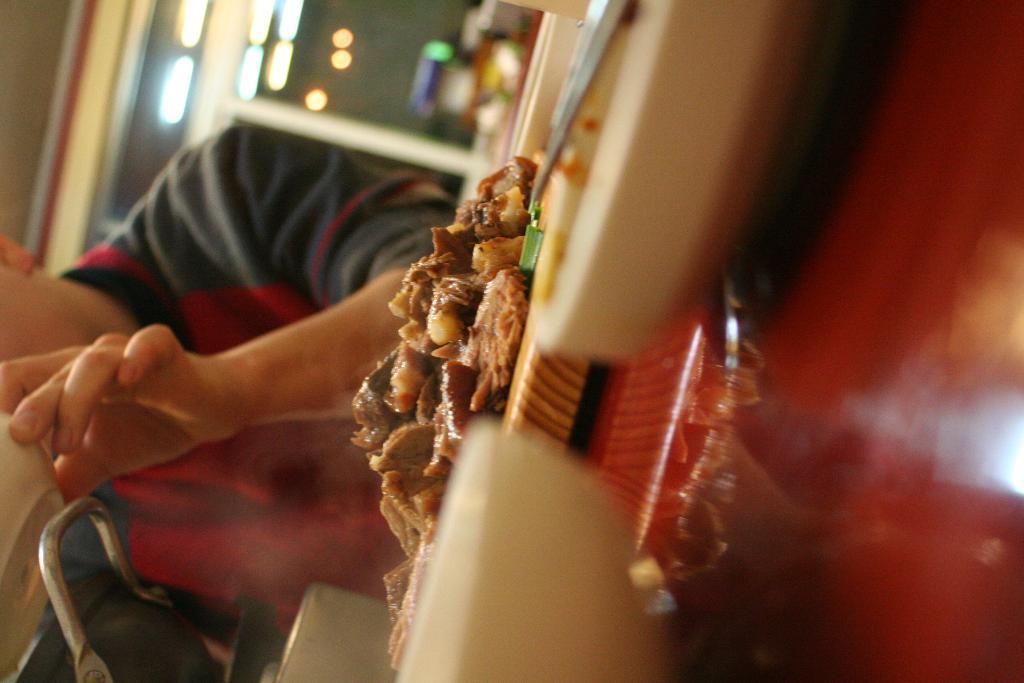In one or two sentences, can you explain what this image depicts? In this picture we can see a man, he is seated on the chair, and he is holding a bowl, in front of him we can see food on the table, in the background we can find few lights. 